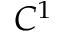<formula> <loc_0><loc_0><loc_500><loc_500>C ^ { 1 }</formula> 